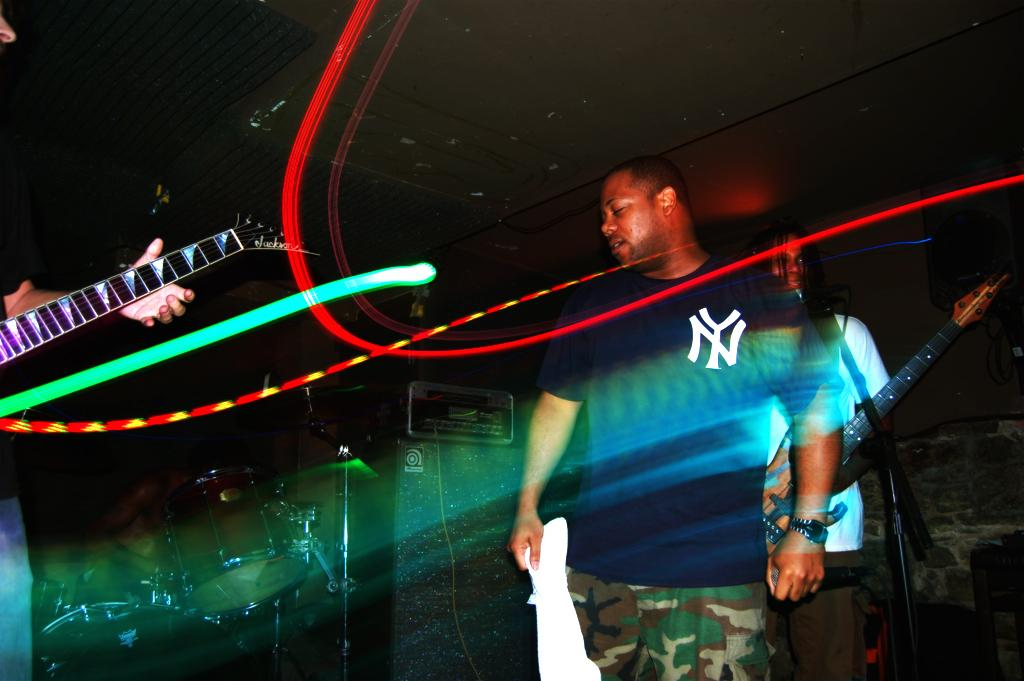What is the main subject of the image? There is a man standing in the image. Can you describe the other person in the image? The other person is holding a guitar. What might the person holding the guitar be doing? The person holding the guitar might be playing or preparing to play the instrument. What type of riddle can be seen written on the wall in the image? There is no riddle visible in the image; it only features a man standing and another person holding a guitar. 